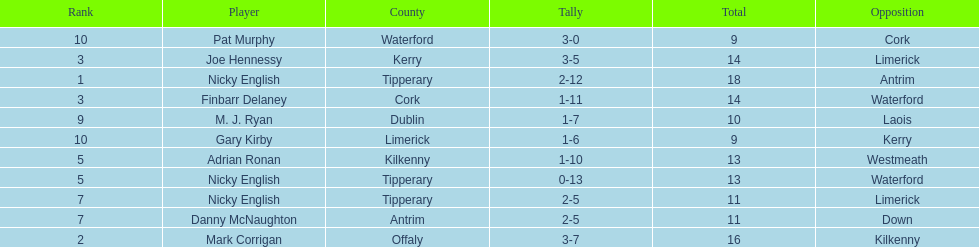Parse the full table. {'header': ['Rank', 'Player', 'County', 'Tally', 'Total', 'Opposition'], 'rows': [['10', 'Pat Murphy', 'Waterford', '3-0', '9', 'Cork'], ['3', 'Joe Hennessy', 'Kerry', '3-5', '14', 'Limerick'], ['1', 'Nicky English', 'Tipperary', '2-12', '18', 'Antrim'], ['3', 'Finbarr Delaney', 'Cork', '1-11', '14', 'Waterford'], ['9', 'M. J. Ryan', 'Dublin', '1-7', '10', 'Laois'], ['10', 'Gary Kirby', 'Limerick', '1-6', '9', 'Kerry'], ['5', 'Adrian Ronan', 'Kilkenny', '1-10', '13', 'Westmeath'], ['5', 'Nicky English', 'Tipperary', '0-13', '13', 'Waterford'], ['7', 'Nicky English', 'Tipperary', '2-5', '11', 'Limerick'], ['7', 'Danny McNaughton', 'Antrim', '2-5', '11', 'Down'], ['2', 'Mark Corrigan', 'Offaly', '3-7', '16', 'Kilkenny']]} What is the least total on the list? 9. 